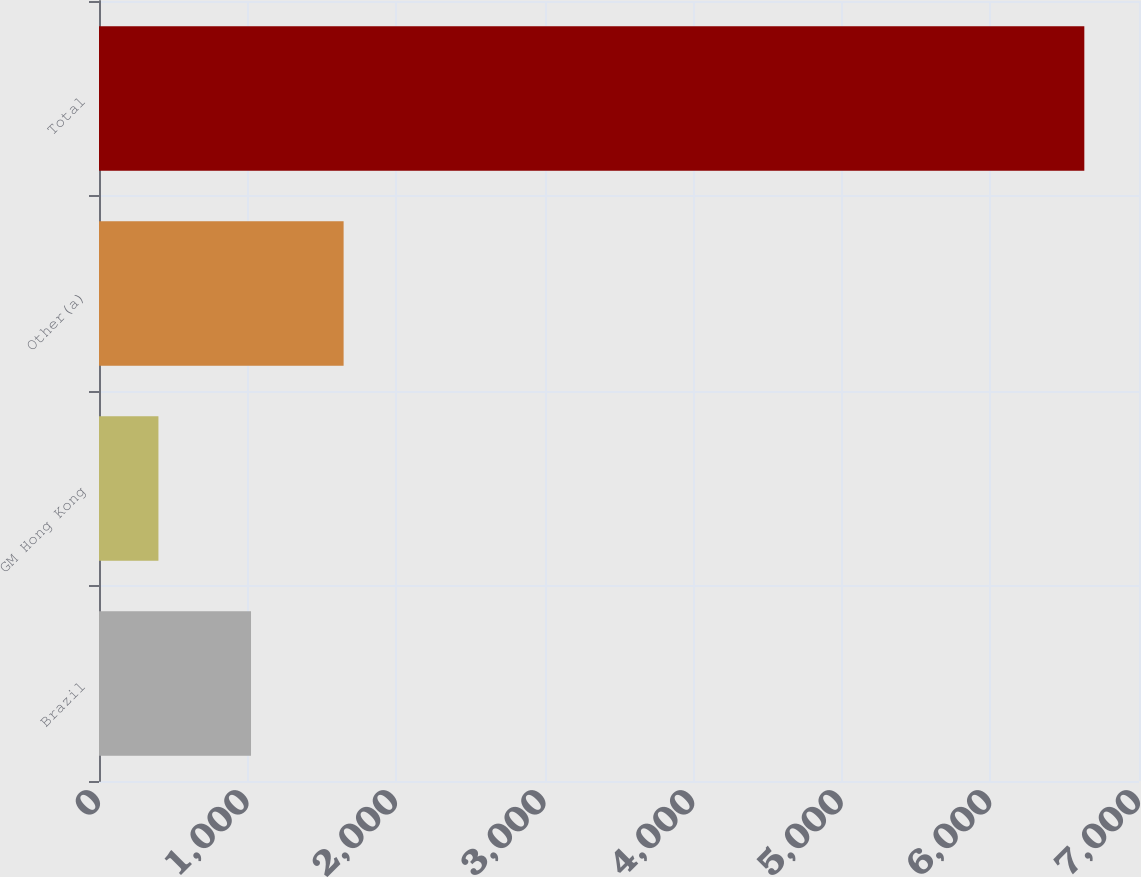Convert chart to OTSL. <chart><loc_0><loc_0><loc_500><loc_500><bar_chart><fcel>Brazil<fcel>GM Hong Kong<fcel>Other(a)<fcel>Total<nl><fcel>1023.2<fcel>400<fcel>1646.4<fcel>6632<nl></chart> 